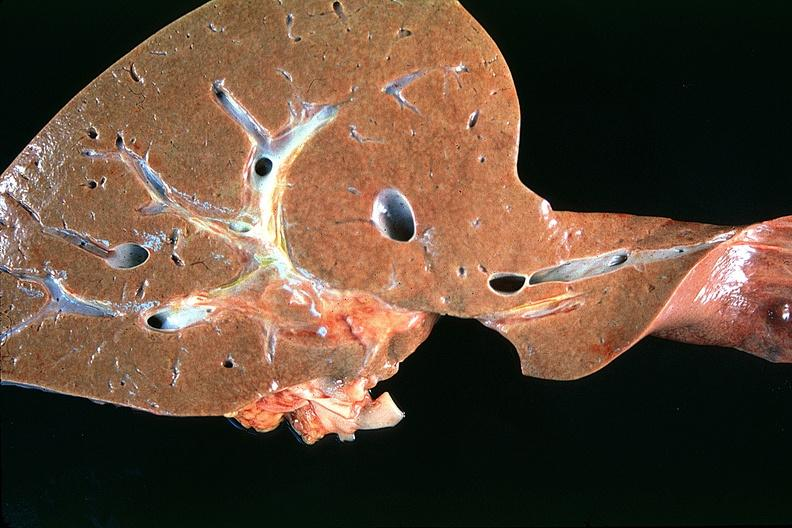does linear fracture in occiput show normal liver?
Answer the question using a single word or phrase. No 